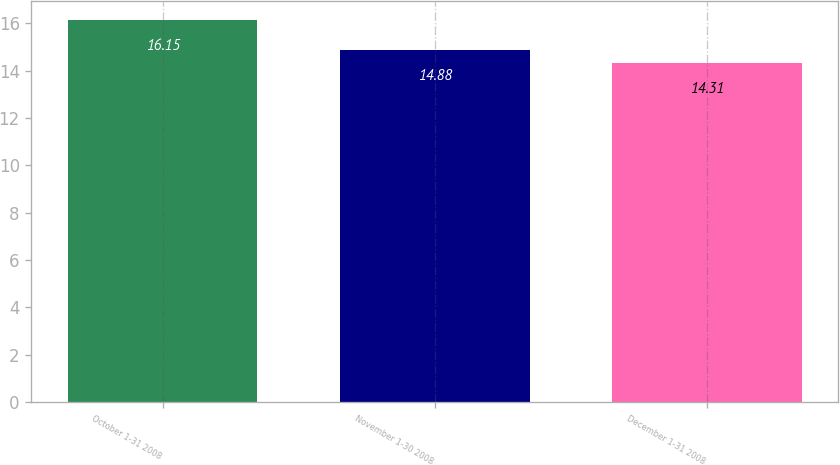Convert chart to OTSL. <chart><loc_0><loc_0><loc_500><loc_500><bar_chart><fcel>October 1-31 2008<fcel>November 1-30 2008<fcel>December 1-31 2008<nl><fcel>16.15<fcel>14.88<fcel>14.31<nl></chart> 